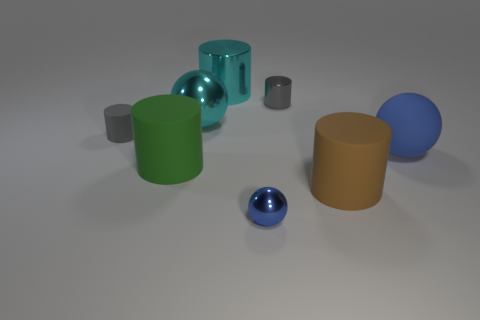How many objects are both to the right of the small sphere and left of the large cyan sphere?
Ensure brevity in your answer.  0. There is a large matte object left of the shiny object left of the cyan metal cylinder; is there a matte object that is in front of it?
Give a very brief answer. Yes. There is a brown matte object that is the same size as the blue rubber ball; what shape is it?
Give a very brief answer. Cylinder. Is there a tiny cylinder of the same color as the big shiny cylinder?
Give a very brief answer. No. Do the brown matte thing and the blue rubber object have the same shape?
Offer a very short reply. No. What number of large objects are blue matte objects or cylinders?
Make the answer very short. 4. There is a tiny object that is the same material as the big green cylinder; what is its color?
Your answer should be compact. Gray. What number of other large brown objects have the same material as the brown thing?
Your response must be concise. 0. Is the size of the gray thing that is on the right side of the green rubber cylinder the same as the shiny ball that is in front of the big green object?
Offer a terse response. Yes. What is the material of the gray cylinder that is behind the tiny gray thing left of the gray metal cylinder?
Your response must be concise. Metal. 